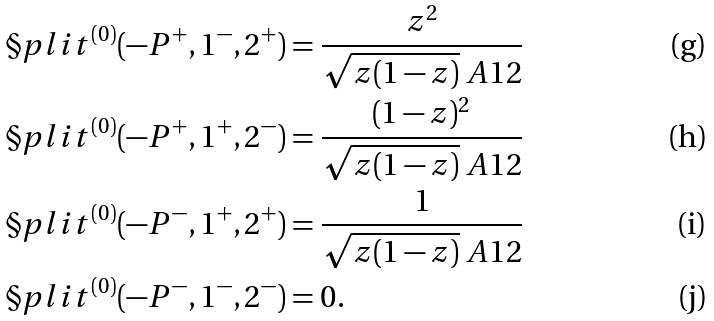Convert formula to latex. <formula><loc_0><loc_0><loc_500><loc_500>\S p l i t ^ { ( 0 ) } ( - P ^ { + } , 1 ^ { - } , 2 ^ { + } ) & = \frac { z ^ { 2 } } { \sqrt { z ( 1 - z ) } \ A { 1 } { 2 } } \\ \S p l i t ^ { ( 0 ) } ( - P ^ { + } , 1 ^ { + } , 2 ^ { - } ) & = \frac { ( 1 - z ) ^ { 2 } } { \sqrt { z ( 1 - z ) } \ A { 1 } { 2 } } \\ \S p l i t ^ { ( 0 ) } ( - P ^ { - } , 1 ^ { + } , 2 ^ { + } ) & = \frac { 1 } { \sqrt { z ( 1 - z ) } \ A { 1 } { 2 } } \\ \S p l i t ^ { ( 0 ) } ( - P ^ { - } , 1 ^ { - } , 2 ^ { - } ) & = 0 .</formula> 